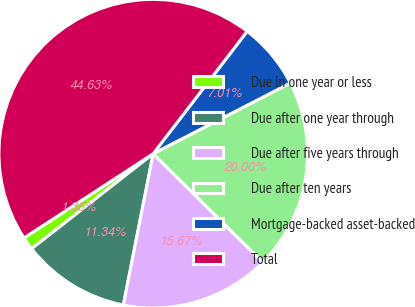Convert chart to OTSL. <chart><loc_0><loc_0><loc_500><loc_500><pie_chart><fcel>Due in one year or less<fcel>Due after one year through<fcel>Due after five years through<fcel>Due after ten years<fcel>Mortgage-backed asset-backed<fcel>Total<nl><fcel>1.36%<fcel>11.34%<fcel>15.67%<fcel>20.0%<fcel>7.01%<fcel>44.63%<nl></chart> 